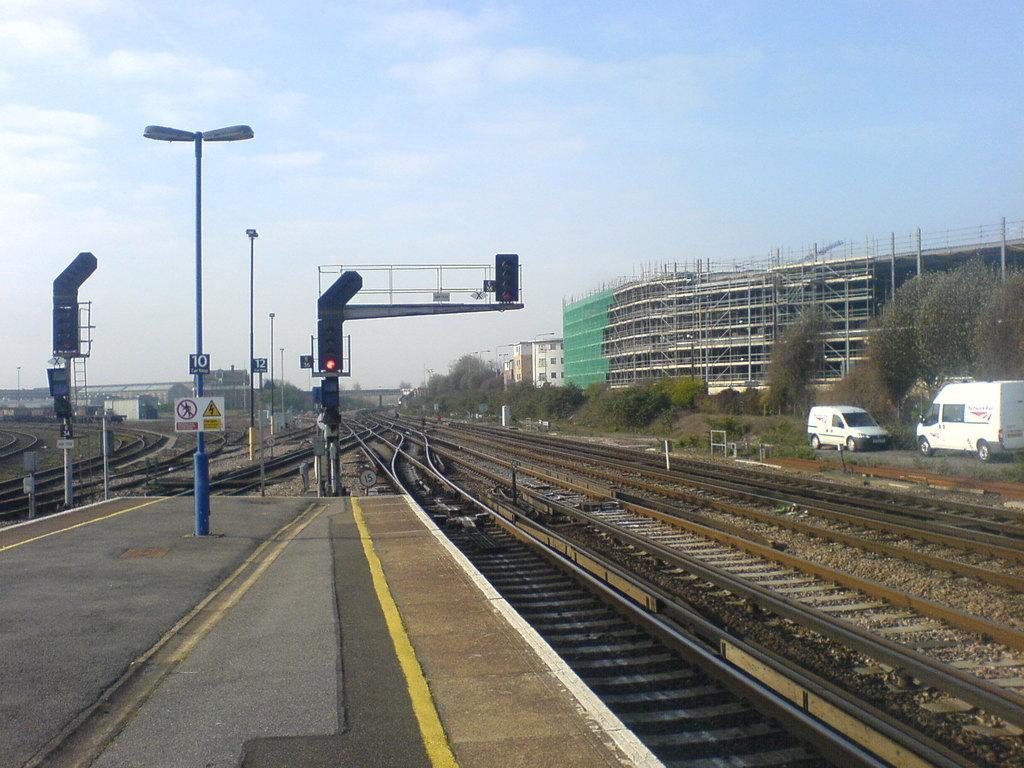Could you give a brief overview of what you see in this image? In this picture we can see the platform, railway tracks, traffic signals, sign boards, light poles, vehicles, trees, buildings and some objects and in the background we can see the sky. 